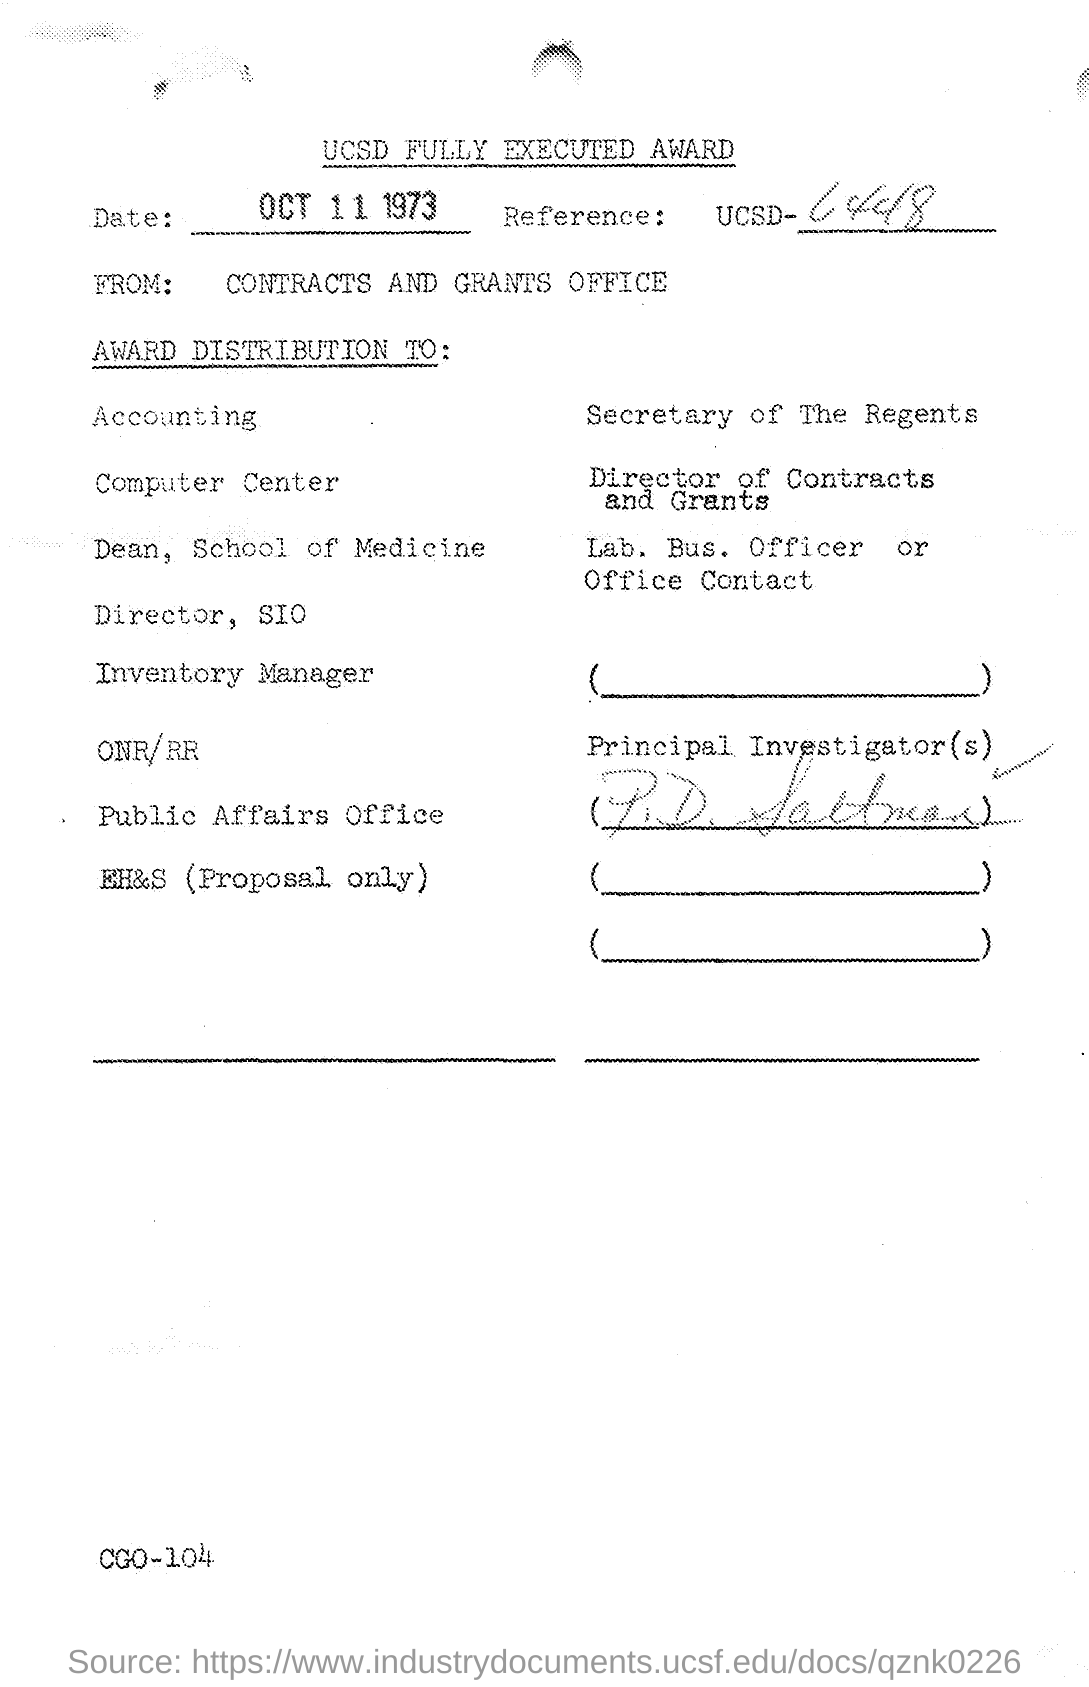Outline some significant characteristics in this image. The date mentioned is October 11, 1973. 